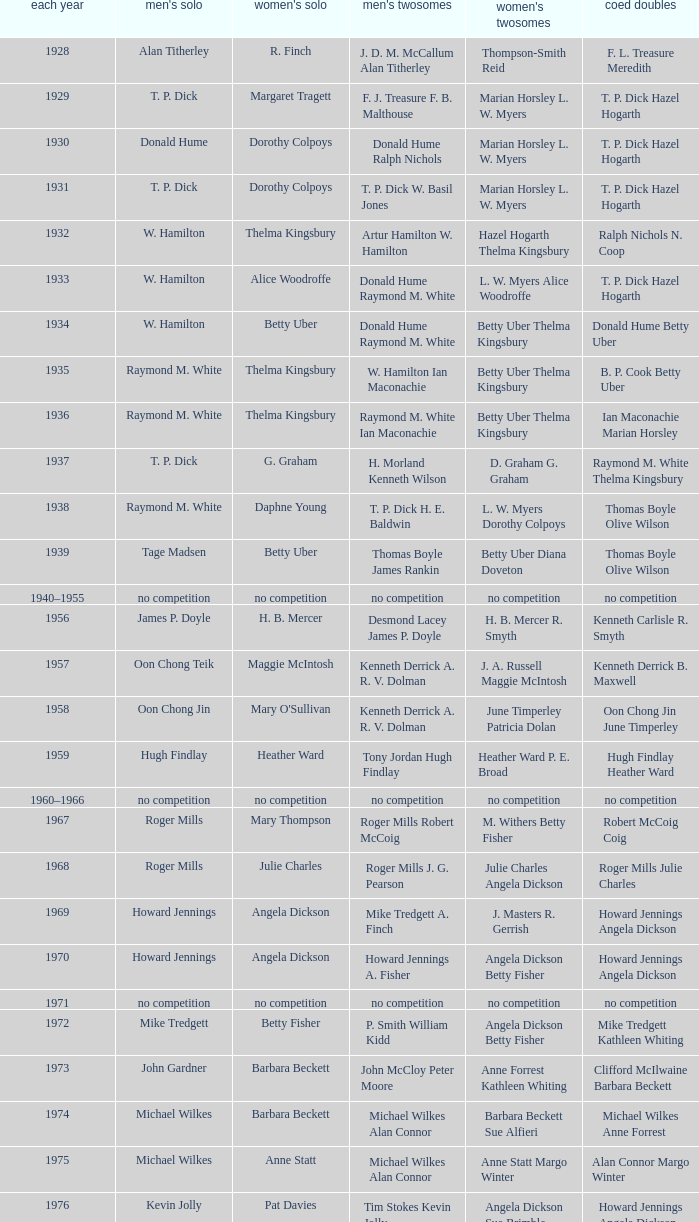Who won the Women's doubles in the year that Billy Gilliland Karen Puttick won the Mixed doubles? Jane Webster Karen Puttick. 